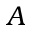<formula> <loc_0><loc_0><loc_500><loc_500>A</formula> 